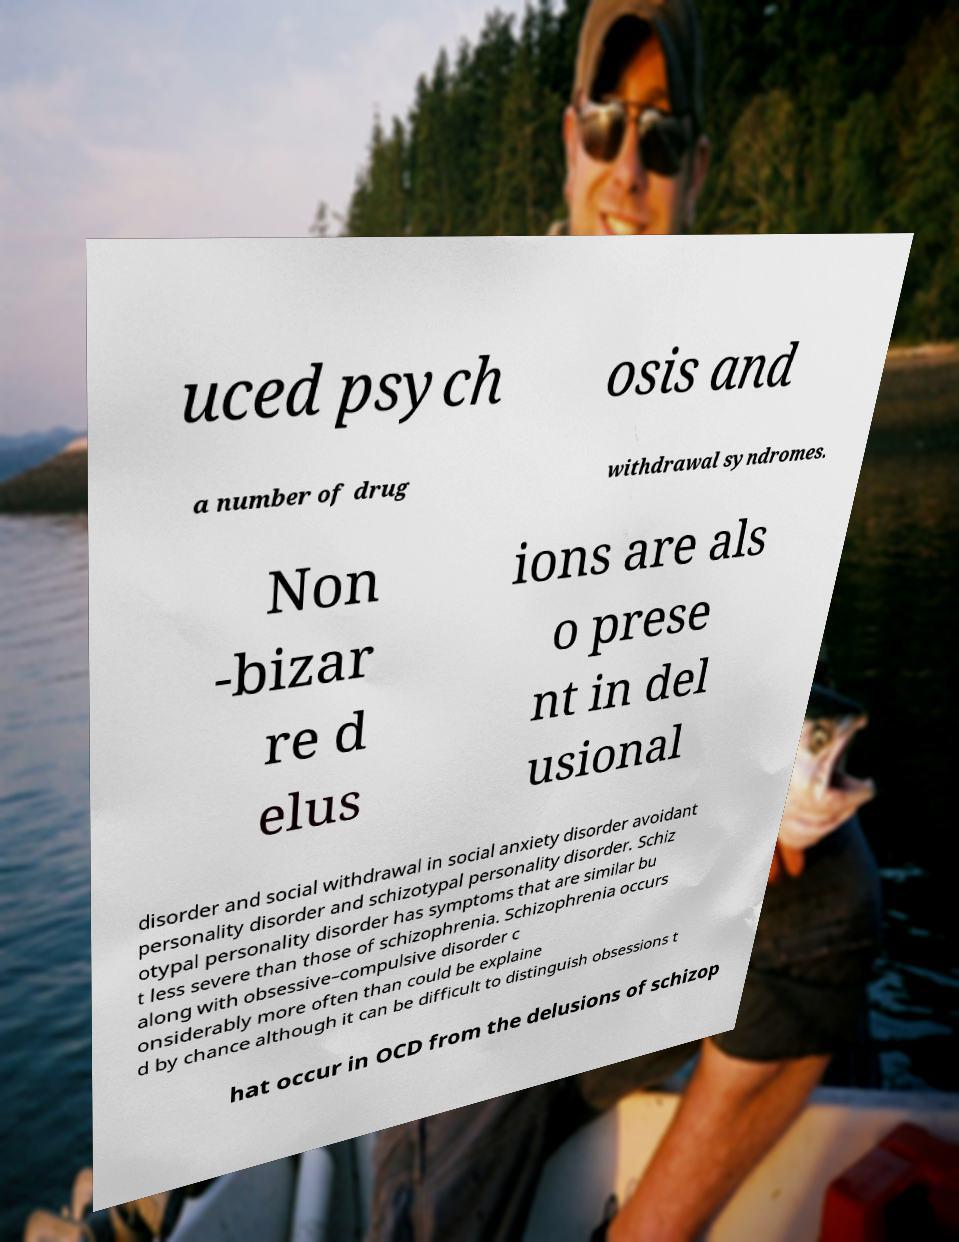I need the written content from this picture converted into text. Can you do that? uced psych osis and a number of drug withdrawal syndromes. Non -bizar re d elus ions are als o prese nt in del usional disorder and social withdrawal in social anxiety disorder avoidant personality disorder and schizotypal personality disorder. Schiz otypal personality disorder has symptoms that are similar bu t less severe than those of schizophrenia. Schizophrenia occurs along with obsessive–compulsive disorder c onsiderably more often than could be explaine d by chance although it can be difficult to distinguish obsessions t hat occur in OCD from the delusions of schizop 